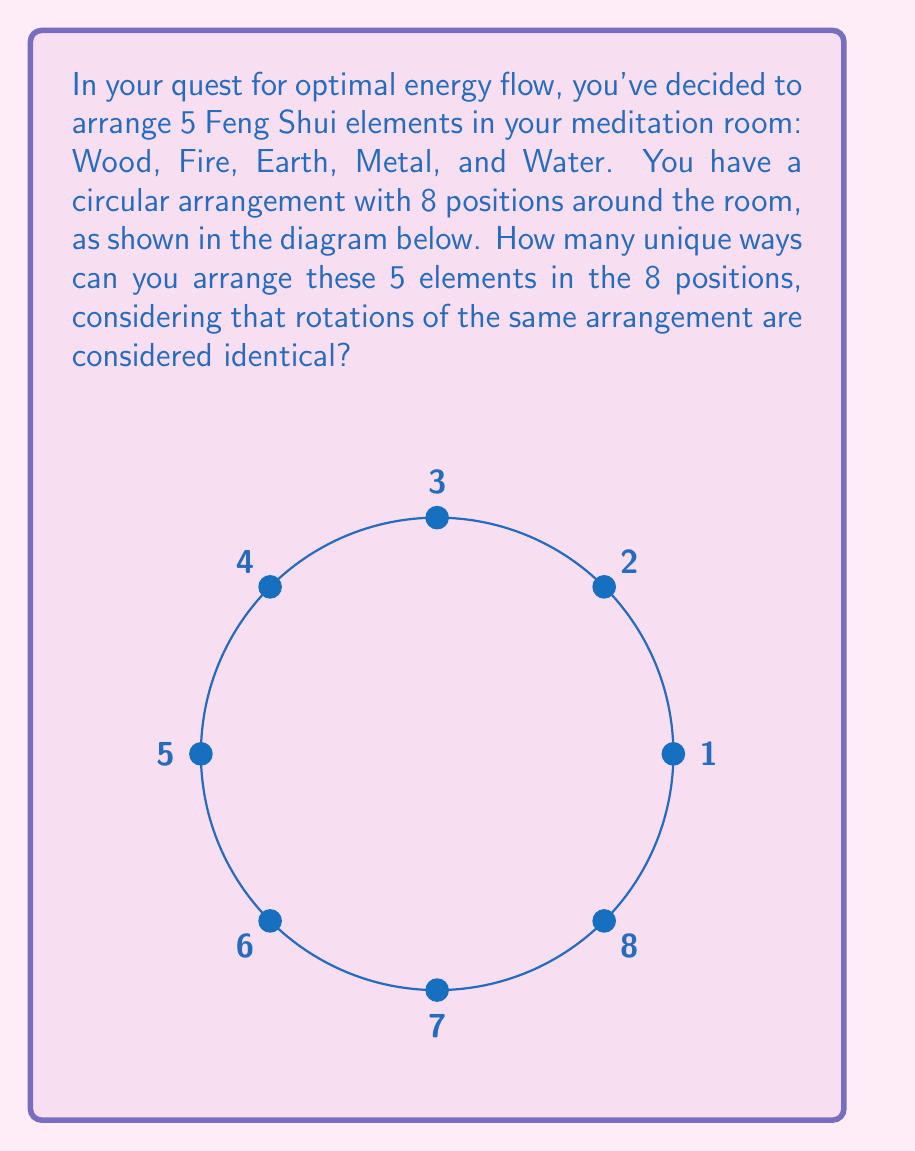Help me with this question. Let's approach this step-by-step:

1) First, we need to calculate the total number of ways to arrange 5 elements in 8 positions without considering rotations. This is a straightforward permutation:

   $$P(8,5) = \frac{8!}{(8-5)!} = \frac{8!}{3!} = 6720$$

2) However, we need to consider that rotations of the same arrangement are identical. There are 8 possible rotations for each unique arrangement (including the original arrangement).

3) To account for this, we need to divide our total number of arrangements by 8:

   $$\frac{6720}{8} = 840$$

4) But we're not done yet! We've overcounted. Consider this: arrangements that have a period of 2, 4, or 8 (i.e., they repeat after 2, 4, or 8 rotations) have been undercounted.

5) For arrangements with a period of 2, we've counted each unique arrangement 4 times instead of 8. There are $\binom{4}{2} = 6$ such arrangements.

6) For arrangements with a period of 4, we've counted each unique arrangement 2 times instead of 8. There is $\binom{4}{1} = 4$ such arrangement.

7) For arrangements with a period of 8 (all elements placed), we've counted it once instead of 8 times. There is $\binom{4}{0} = 1$ such arrangement.

8) We need to add these back:

   $$840 + 6 \cdot \frac{8}{4} + 4 \cdot \frac{8}{2} + 1 \cdot \frac{8}{1} = 840 + 12 + 16 + 8 = 876$$

Therefore, there are 876 unique ways to arrange the 5 Feng Shui elements in the 8 positions.
Answer: 876 